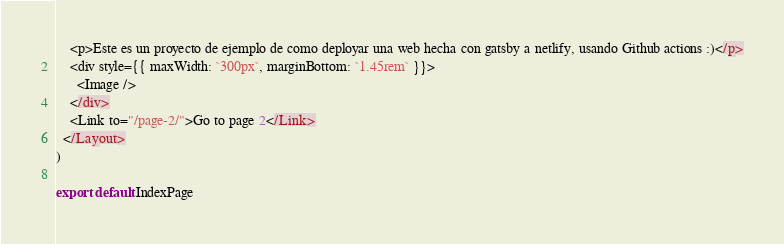<code> <loc_0><loc_0><loc_500><loc_500><_JavaScript_>    <p>Este es un proyecto de ejemplo de como deployar una web hecha con gatsby a netlify, usando Github actions :)</p>
    <div style={{ maxWidth: `300px`, marginBottom: `1.45rem` }}>
      <Image />
    </div>
    <Link to="/page-2/">Go to page 2</Link>
  </Layout>
)

export default IndexPage
</code> 